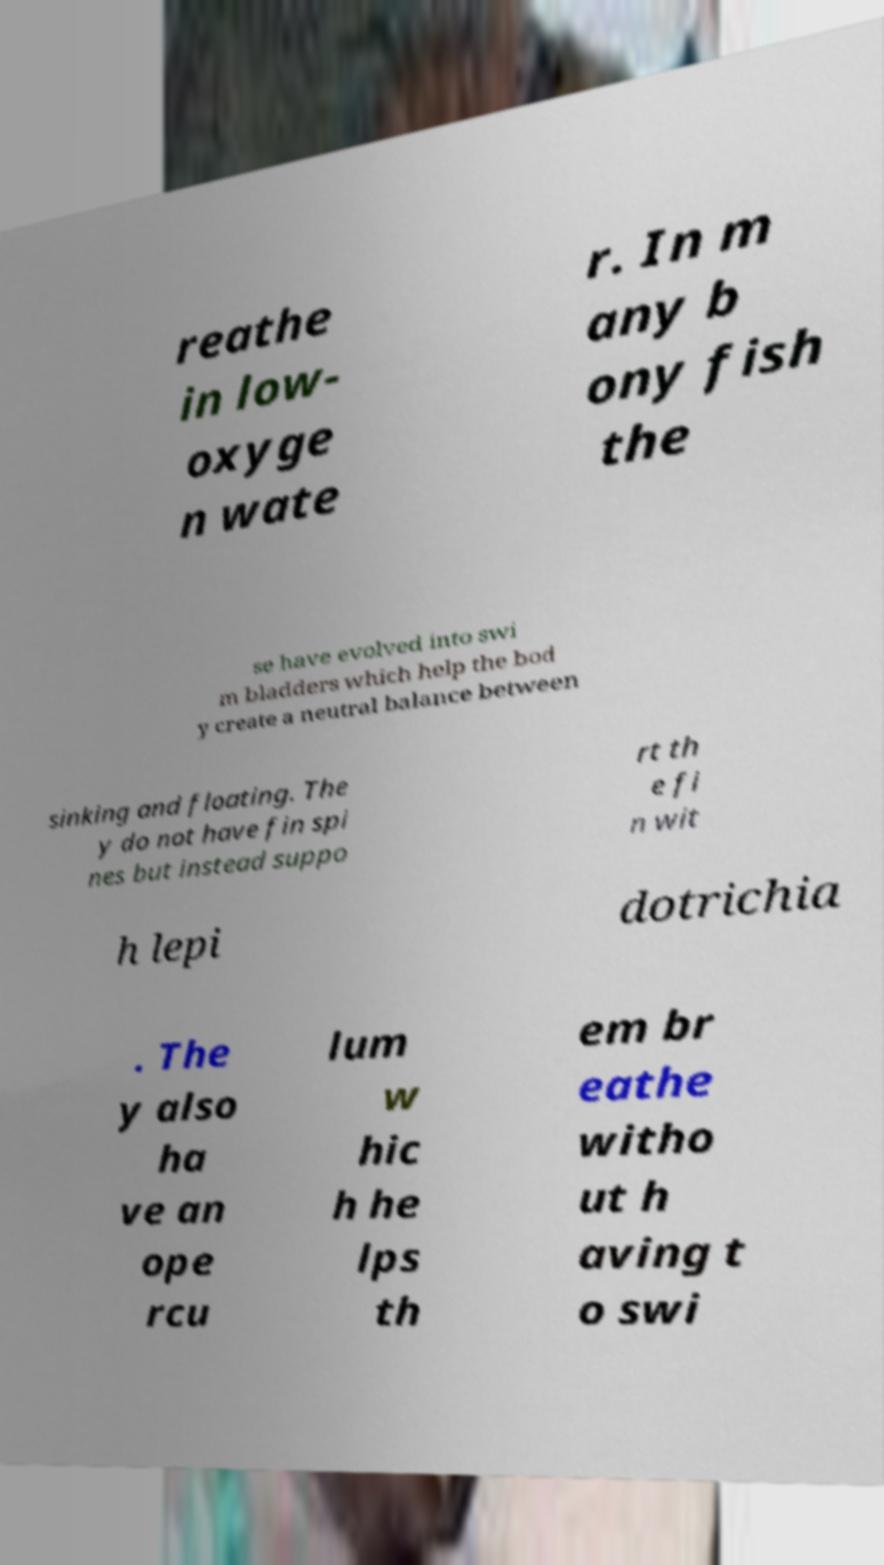Please identify and transcribe the text found in this image. reathe in low- oxyge n wate r. In m any b ony fish the se have evolved into swi m bladders which help the bod y create a neutral balance between sinking and floating. The y do not have fin spi nes but instead suppo rt th e fi n wit h lepi dotrichia . The y also ha ve an ope rcu lum w hic h he lps th em br eathe witho ut h aving t o swi 